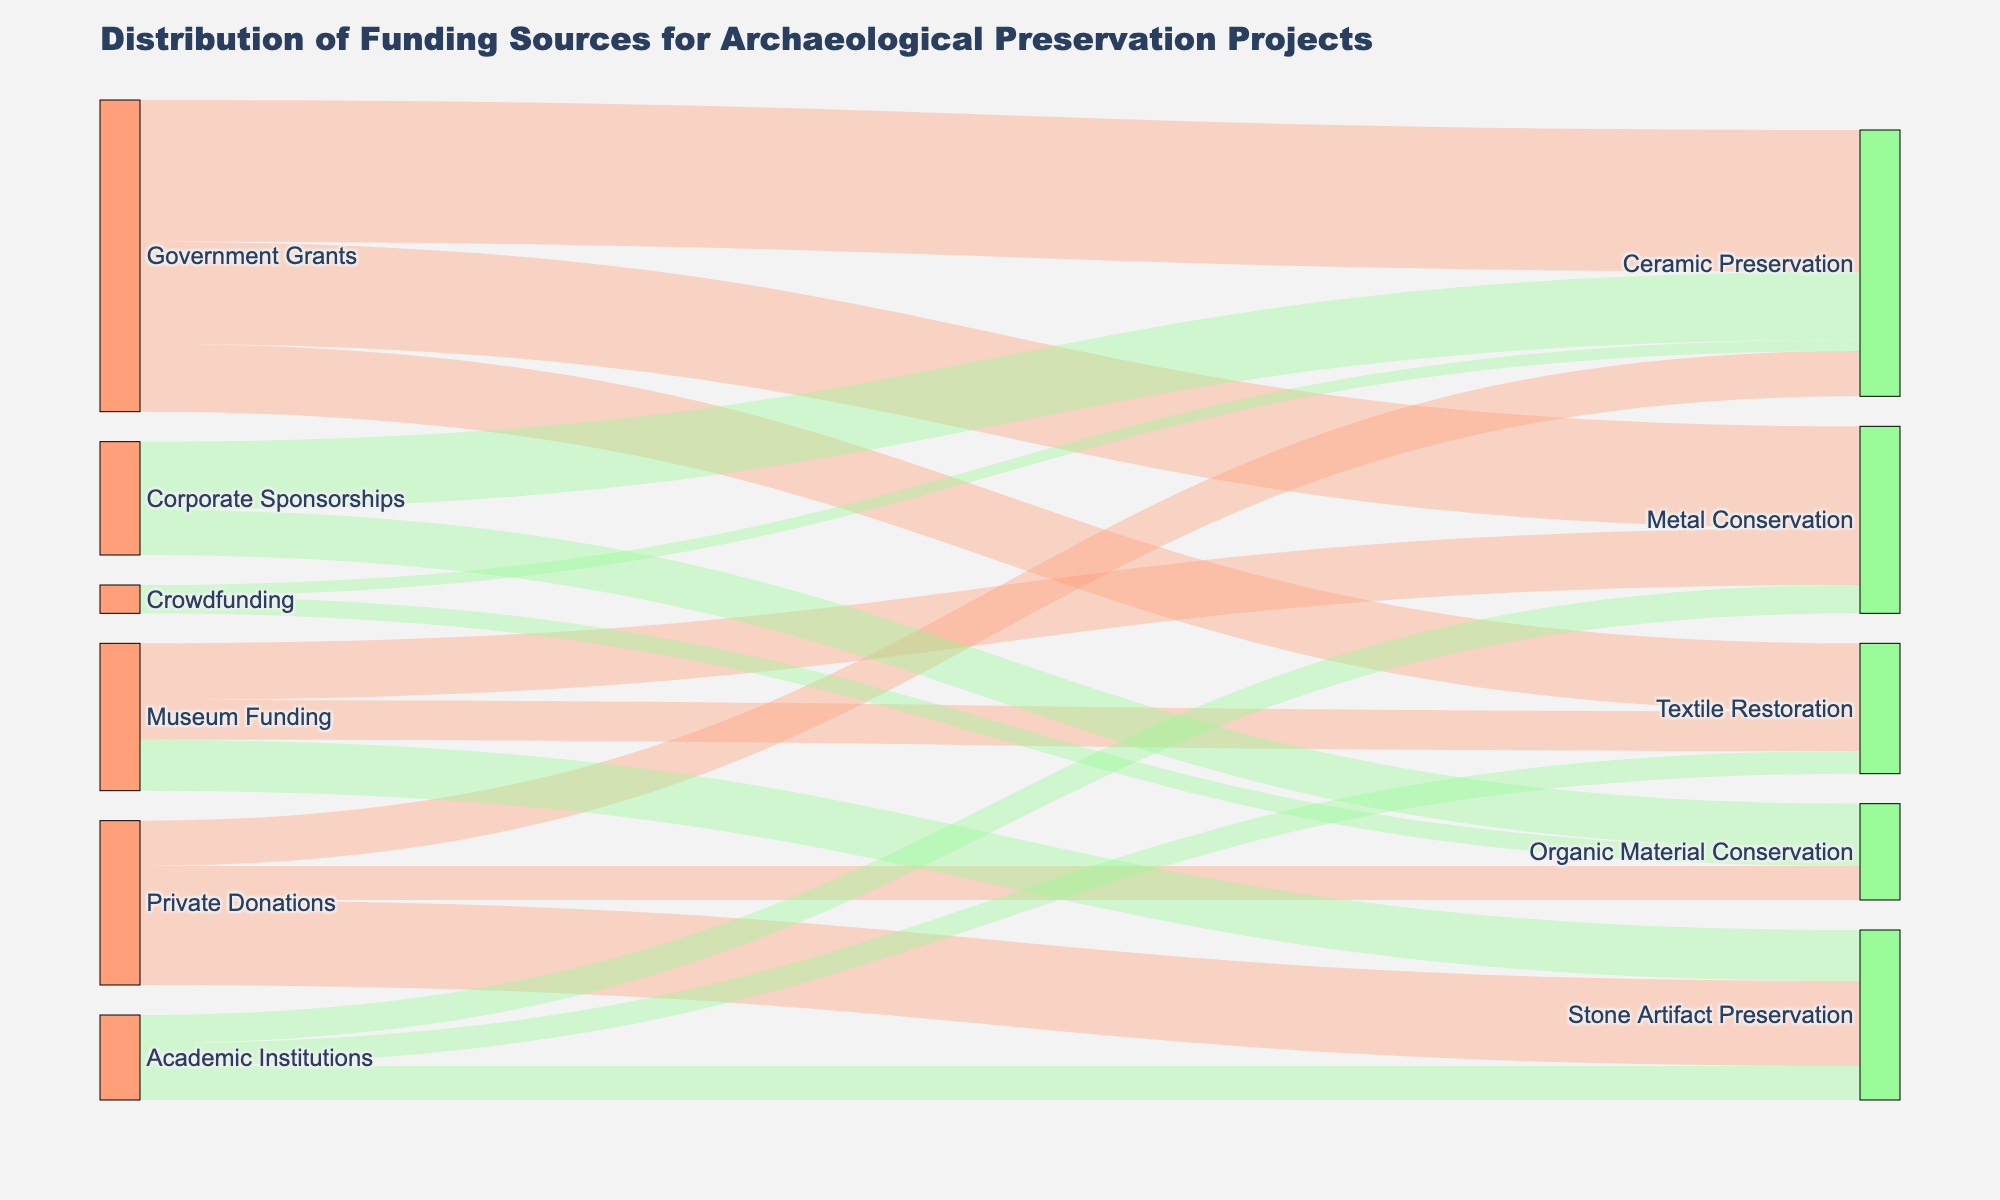What's the main funding source for Ceramic Preservation? To answer this, observe the Sankey diagram and look for the largest link connecting a funding source to Ceramic Preservation. The largest funding source is Government Grants.
Answer: Government Grants Which type of artifact preservation receives the least funding from Private Donations? Examine the branches flowing from Private Donations. Compare the values leading to Ceramic Preservation, Stone Artifact Preservation, and Organic Material Conservation. The smallest value is for Organic Material Conservation.
Answer: Organic Material Conservation How does the funding amount for Textile Restoration from Museum Funding compare to that from Academic Institutions? Locate the links from Museum Funding and Academic Institutions to Textile Restoration. Compare their values; Museum Funding contributes $700,000, while Academic Institutions contribute $400,000.
Answer: Museum Funding is higher What is the total funding for Metal Conservation? Identify and sum all contributions toward Metal Conservation: $1,800,000 from Government Grants, $1,000,000 from Museum Funding, and $500,000 from Academic Institutions. The total is $3,300,000.
Answer: $3,300,000 Which funding source has the least overall contribution and which artifact type receives the most funding? Evaluate the total contributions from each source and compare. Crowdfunding has the least overall contribution. Examine the target nodes and the associated values to find that Ceramic Preservation receives the most funding overall, largely from Government Grants and Corporate Sponsorships.
Answer: Crowdfunding; Ceramic Preservation How much more funding does Stone Artifact Preservation receive from Private Donations compared to Academic Institutions? Compare the funding amounts for Stone Artifact Preservation: Private Donations contribute $1,500,000, while Academic Institutions contribute $600,000. Subtract the smaller from the larger ($1,500,000 - $600,000).
Answer: $900,000 What percentage of Corporate Sponsorships funding goes to Organic Material Conservation? Calculate the total funding from Corporate Sponsorships: $1,200,000 for Ceramic Preservation and $800,000 for Organic Material Conservation, summing to $2,000,000. The percentage for Organic Material Conservation is ($800,000 / $2,000,000) * 100%.
Answer: 40% Which artifact type receives funding from all sources listed? Trace the branches to see if any target node is connected to all funding sources: Government Grants, Private Donations, Museum Funding, Corporate Sponsorships, Academic Institutions, and Crowdfunding. No artifact type is funded by all sources.
Answer: None 